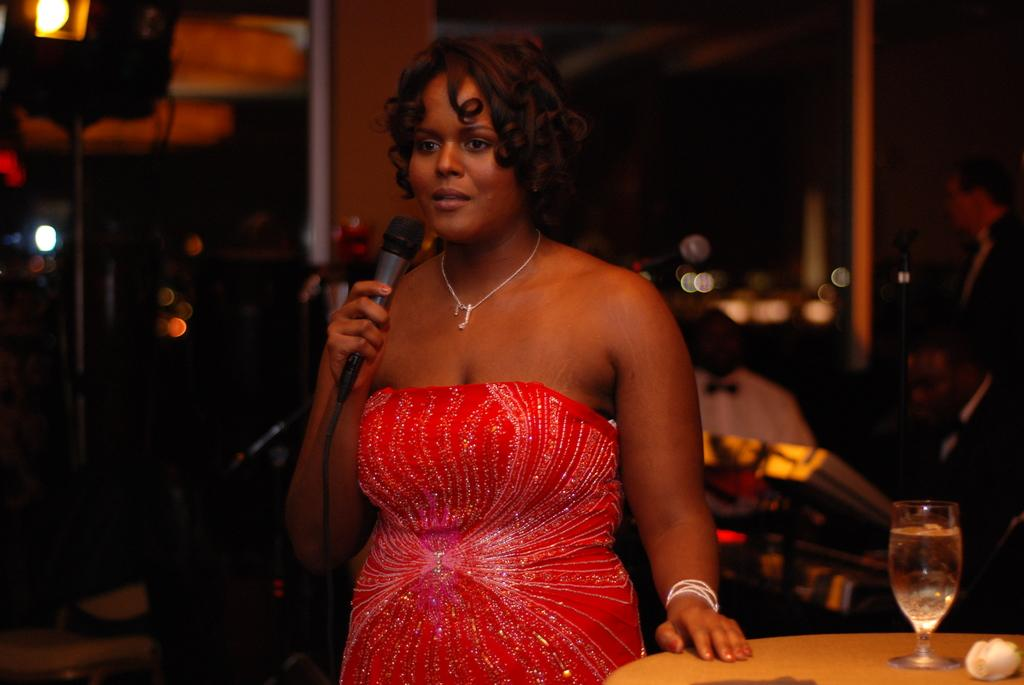Who is the main subject in the image? There is a lady in the image. What is the lady holding in the image? The lady is holding a microphone. What is the lady wearing in the image? The lady is wearing a red dress. What other objects can be seen in the image? There is a table and a wine glass in the image. What is the setting of the image? The background of the image appears to be a bar. What substance is the lady using to clean her mouth in the image? There is no indication in the image that the lady is cleaning her mouth or using any substance for that purpose. 